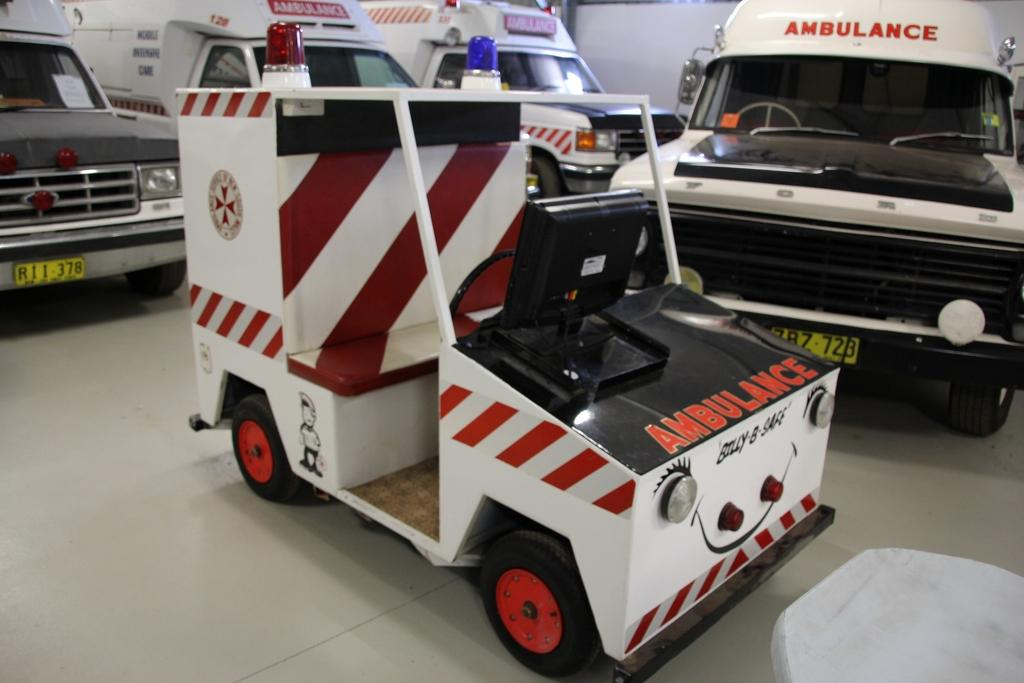What types of objects can be seen in the image? There are vehicles in the image. What part of the image is visible at the bottom? The floor is visible at the bottom of the image. What part of the image is visible at the top? The wall is visible at the top of the image. What type of cloth is draped over the vehicles in the image? There is no cloth draped over the vehicles in the image. What language is spoken by the vehicles in the image? Vehicles do not speak a language, as they are inanimate objects. 